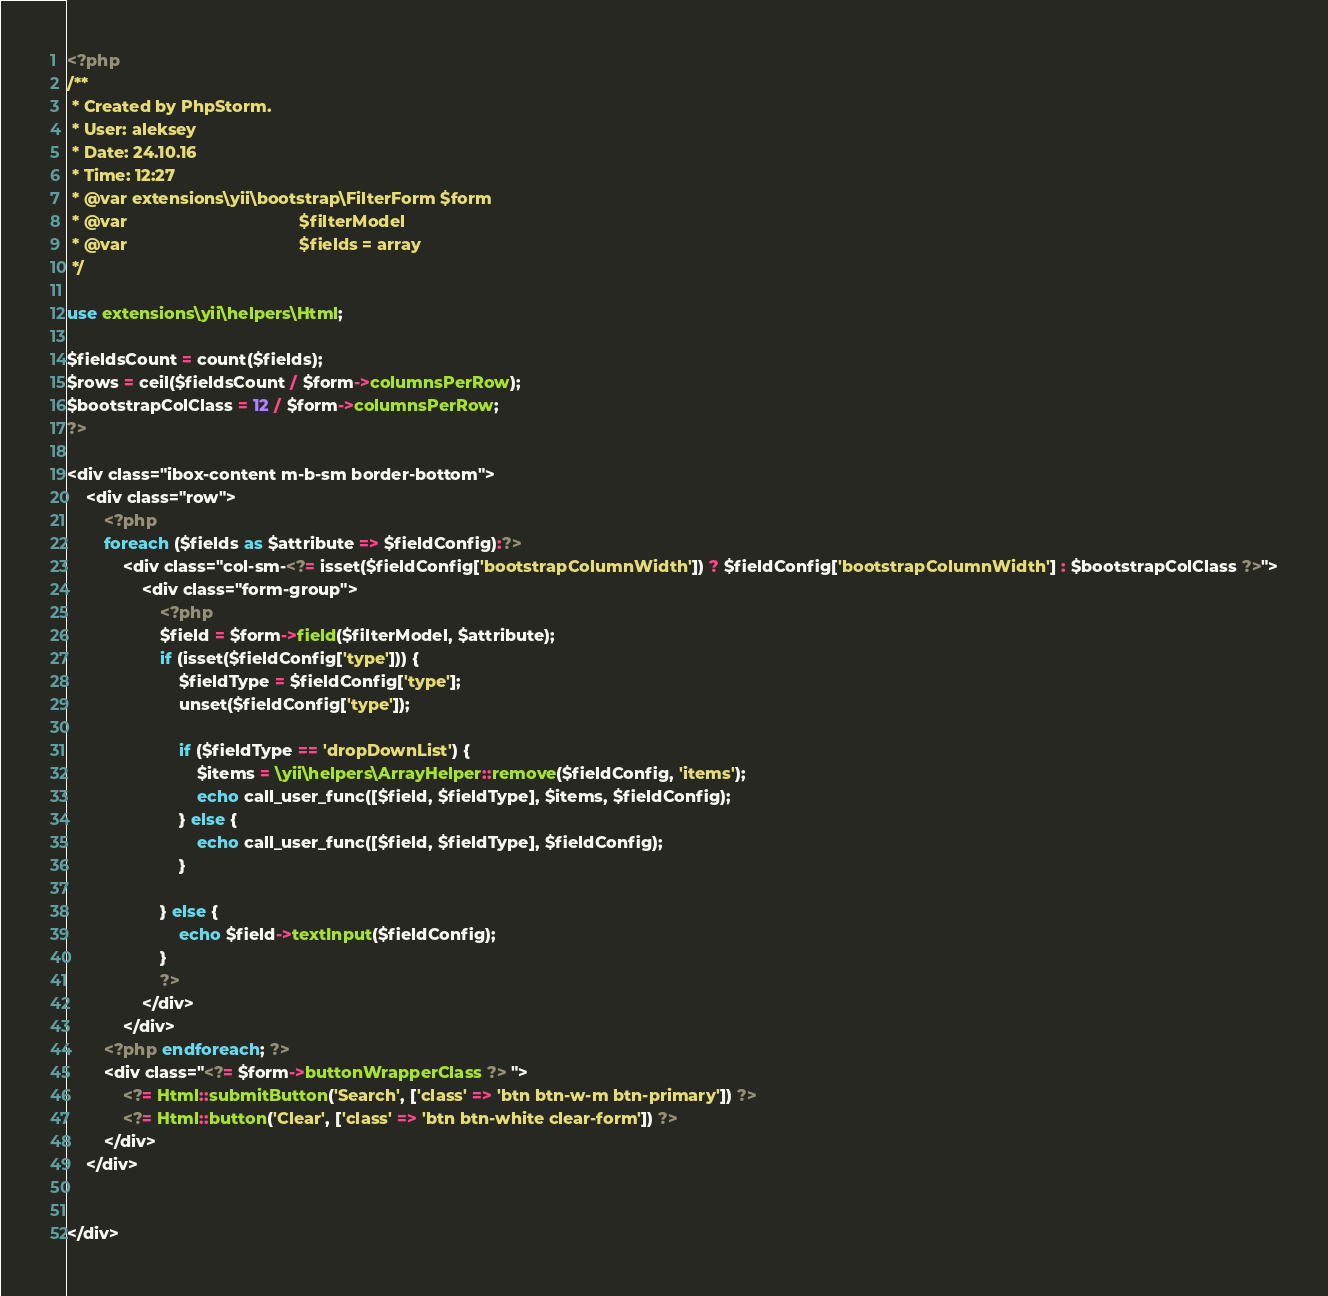<code> <loc_0><loc_0><loc_500><loc_500><_PHP_><?php
/**
 * Created by PhpStorm.
 * User: aleksey
 * Date: 24.10.16
 * Time: 12:27
 * @var extensions\yii\bootstrap\FilterForm $form
 * @var                                     $filterModel
 * @var                                     $fields = array
 */

use extensions\yii\helpers\Html;

$fieldsCount = count($fields);
$rows = ceil($fieldsCount / $form->columnsPerRow);
$bootstrapColClass = 12 / $form->columnsPerRow;
?>

<div class="ibox-content m-b-sm border-bottom">
    <div class="row">
        <?php
        foreach ($fields as $attribute => $fieldConfig):?>
            <div class="col-sm-<?= isset($fieldConfig['bootstrapColumnWidth']) ? $fieldConfig['bootstrapColumnWidth'] : $bootstrapColClass ?>">
                <div class="form-group">
                    <?php
                    $field = $form->field($filterModel, $attribute);
                    if (isset($fieldConfig['type'])) {
                        $fieldType = $fieldConfig['type'];
                        unset($fieldConfig['type']);

                        if ($fieldType == 'dropDownList') {
                            $items = \yii\helpers\ArrayHelper::remove($fieldConfig, 'items');
                            echo call_user_func([$field, $fieldType], $items, $fieldConfig);
                        } else {
                            echo call_user_func([$field, $fieldType], $fieldConfig);
                        }

                    } else {
                        echo $field->textInput($fieldConfig);
                    }
                    ?>
                </div>
            </div>
        <?php endforeach; ?>
        <div class="<?= $form->buttonWrapperClass ?> ">
            <?= Html::submitButton('Search', ['class' => 'btn btn-w-m btn-primary']) ?>
            <?= Html::button('Clear', ['class' => 'btn btn-white clear-form']) ?>
        </div>
    </div>


</div></code> 